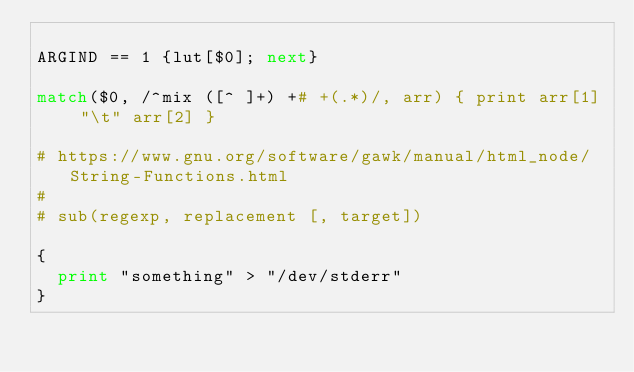Convert code to text. <code><loc_0><loc_0><loc_500><loc_500><_Awk_>
ARGIND == 1 {lut[$0]; next}

match($0, /^mix ([^ ]+) +# +(.*)/, arr) { print arr[1] "\t" arr[2] }

# https://www.gnu.org/software/gawk/manual/html_node/String-Functions.html
#
# sub(regexp, replacement [, target])

{
  print "something" > "/dev/stderr"
}

</code> 